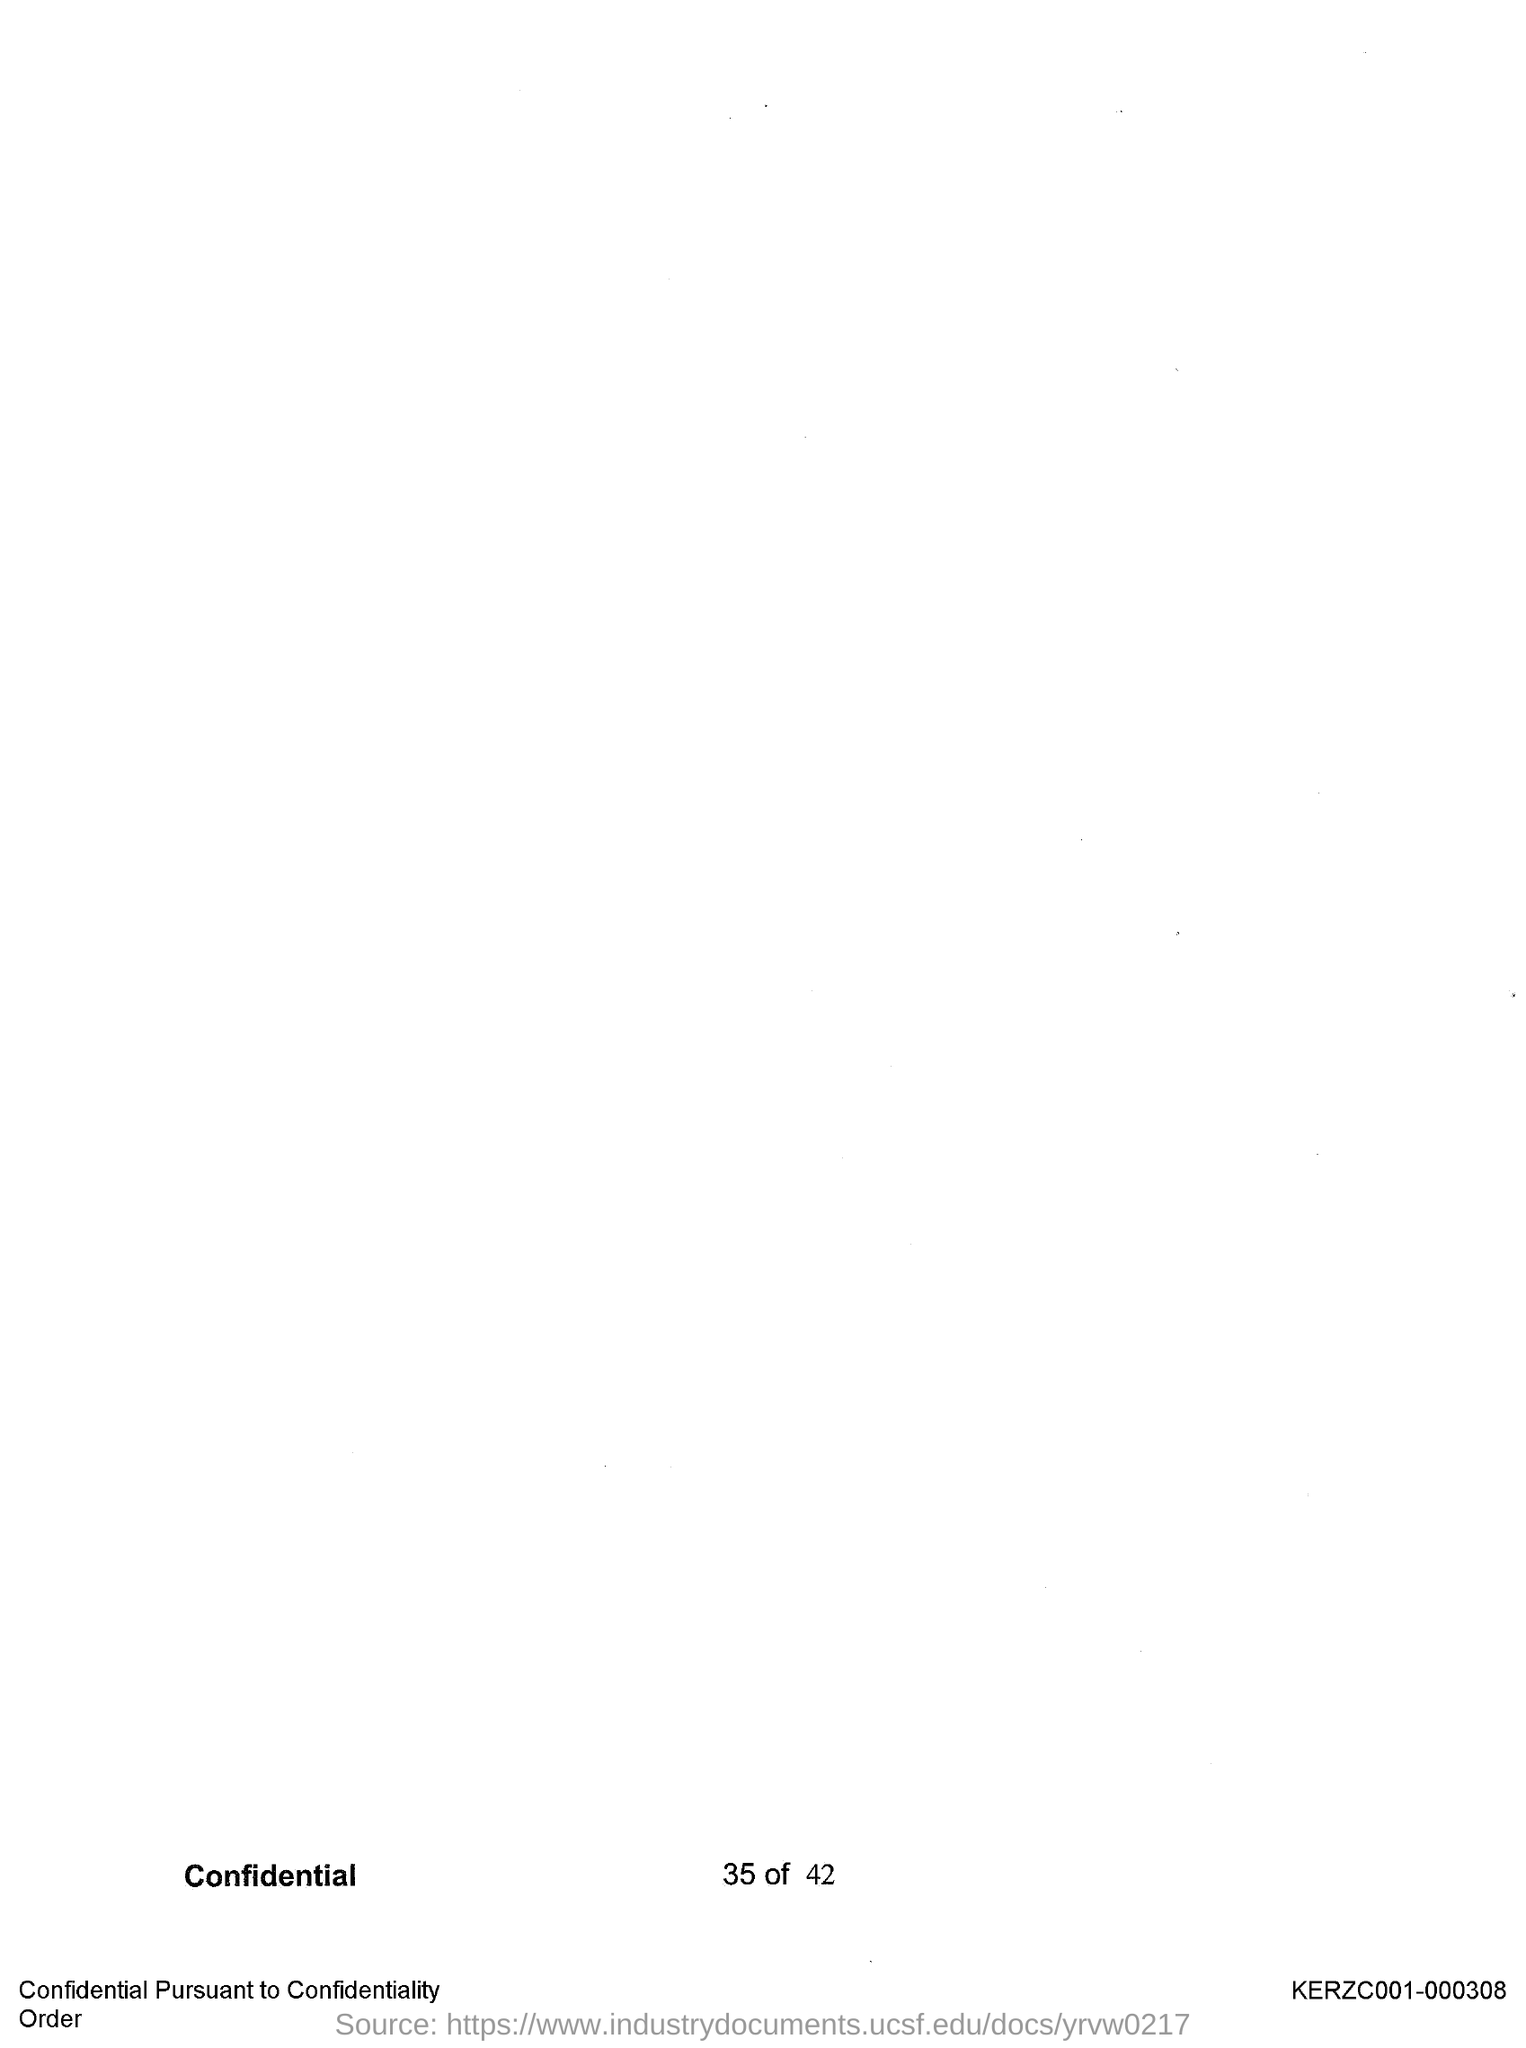Point out several critical features in this image. According to this document, page 35 of 42 was mentioned. 